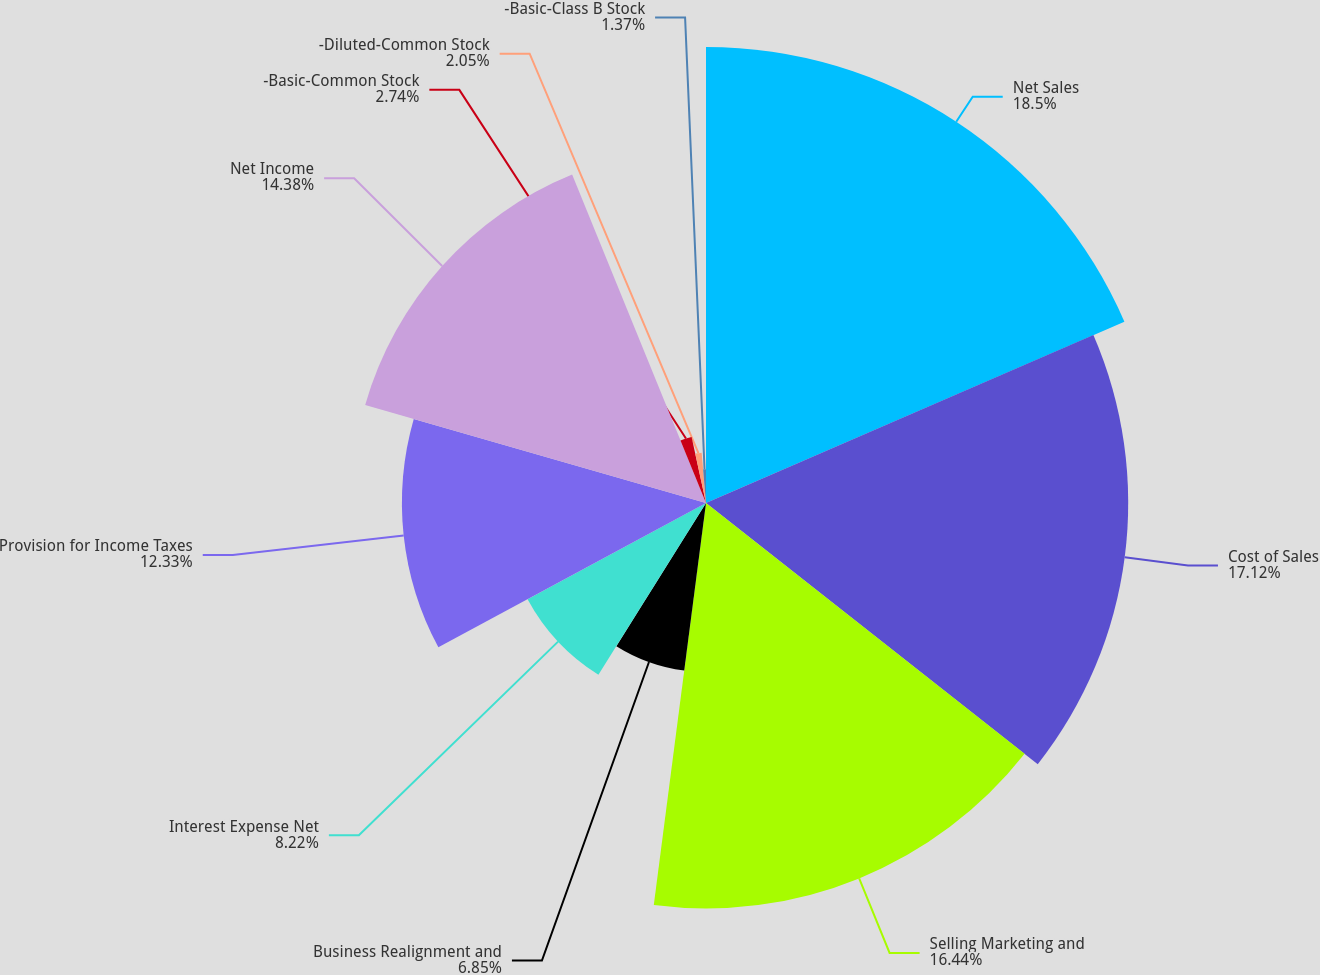Convert chart to OTSL. <chart><loc_0><loc_0><loc_500><loc_500><pie_chart><fcel>Net Sales<fcel>Cost of Sales<fcel>Selling Marketing and<fcel>Business Realignment and<fcel>Interest Expense Net<fcel>Provision for Income Taxes<fcel>Net Income<fcel>-Basic-Common Stock<fcel>-Diluted-Common Stock<fcel>-Basic-Class B Stock<nl><fcel>18.49%<fcel>17.12%<fcel>16.44%<fcel>6.85%<fcel>8.22%<fcel>12.33%<fcel>14.38%<fcel>2.74%<fcel>2.05%<fcel>1.37%<nl></chart> 